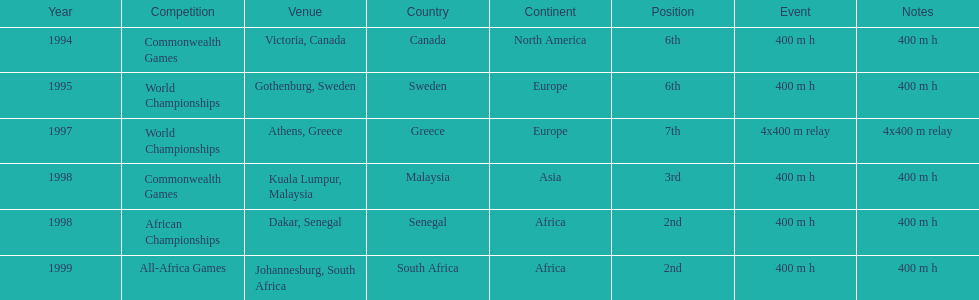What is the total number of competitions on this chart? 6. 